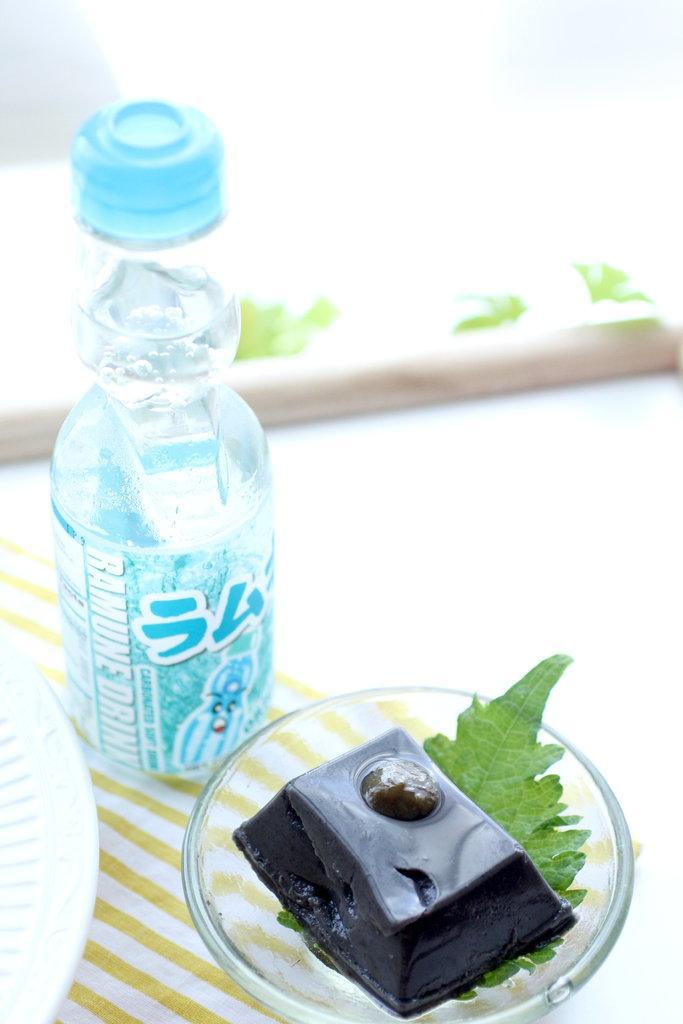Can you describe this image briefly? This image consists of a water bottle, plate and a bowl. In the bowl there are some eatables. The bottle is in blue color. 